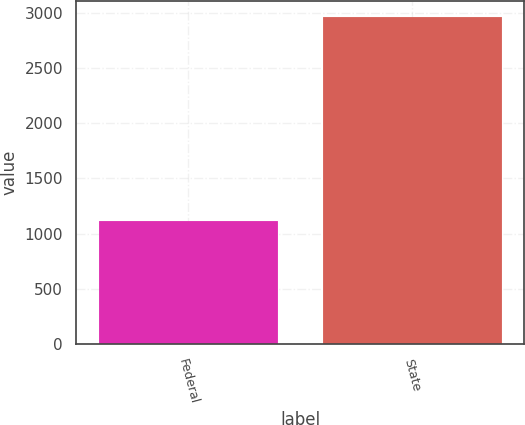Convert chart to OTSL. <chart><loc_0><loc_0><loc_500><loc_500><bar_chart><fcel>Federal<fcel>State<nl><fcel>1116<fcel>2958<nl></chart> 